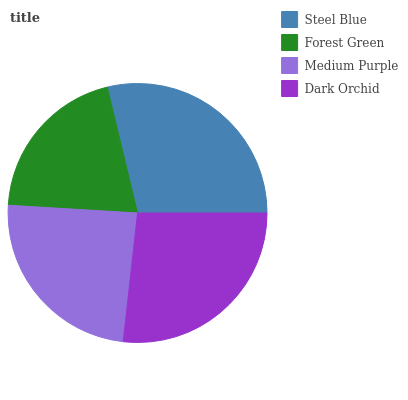Is Forest Green the minimum?
Answer yes or no. Yes. Is Steel Blue the maximum?
Answer yes or no. Yes. Is Medium Purple the minimum?
Answer yes or no. No. Is Medium Purple the maximum?
Answer yes or no. No. Is Medium Purple greater than Forest Green?
Answer yes or no. Yes. Is Forest Green less than Medium Purple?
Answer yes or no. Yes. Is Forest Green greater than Medium Purple?
Answer yes or no. No. Is Medium Purple less than Forest Green?
Answer yes or no. No. Is Dark Orchid the high median?
Answer yes or no. Yes. Is Medium Purple the low median?
Answer yes or no. Yes. Is Steel Blue the high median?
Answer yes or no. No. Is Forest Green the low median?
Answer yes or no. No. 